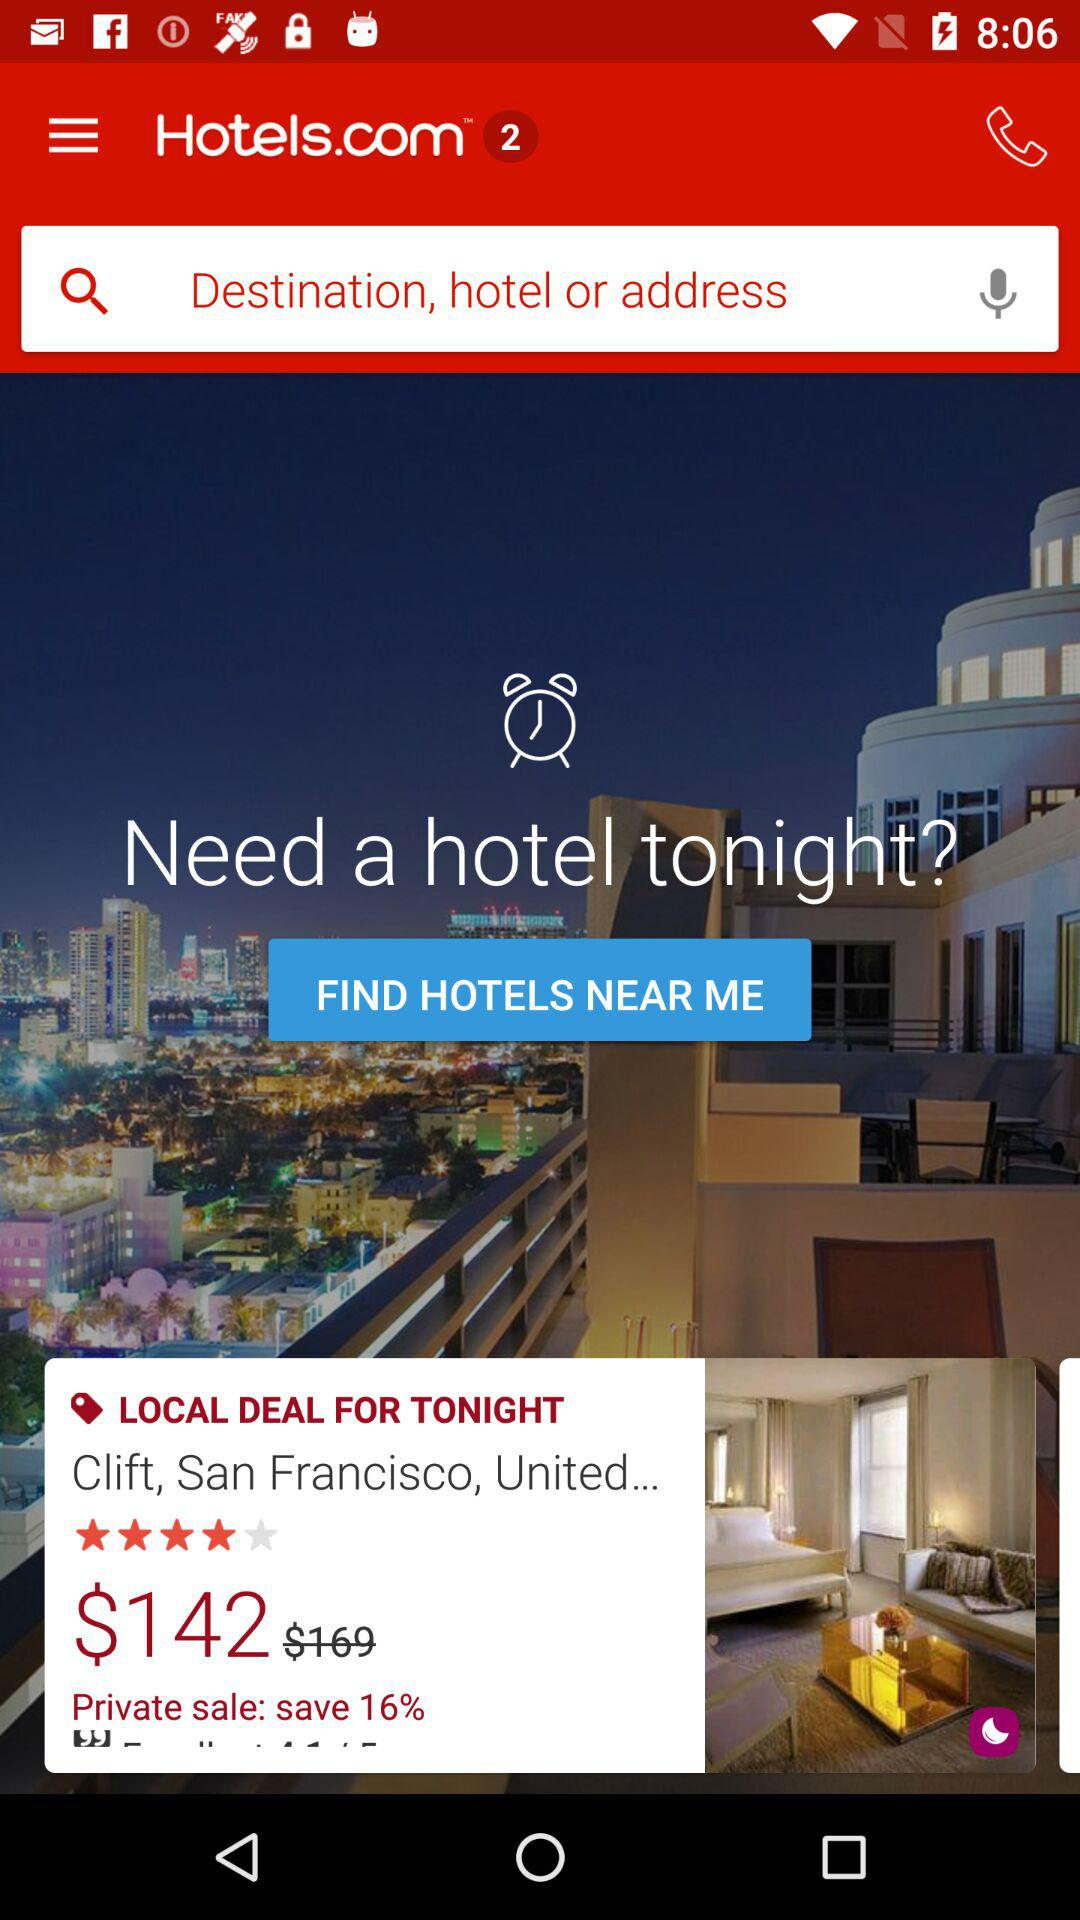How much is the discount percentage on the private sale? The discount on the private sale is 16%. 